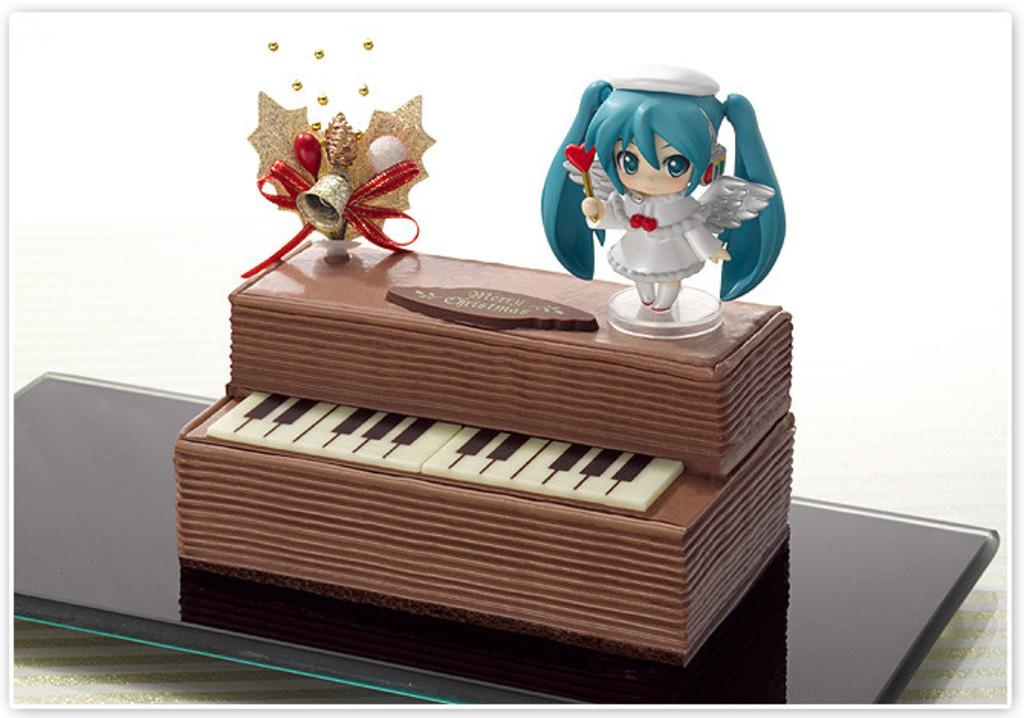What is the main subject of the image? The main subject of the image is a cake with text. What other items are visible in the image? There are keys and toys in the image. How are the cake, keys, and toys arranged? The cake, keys, and toys are placed on a plate. Where is the plate located? The plate is kept on a surface. What type of chalk is being used to write the text on the cake? There is no chalk present in the image; the text on the cake is likely written with icing or another edible substance. 